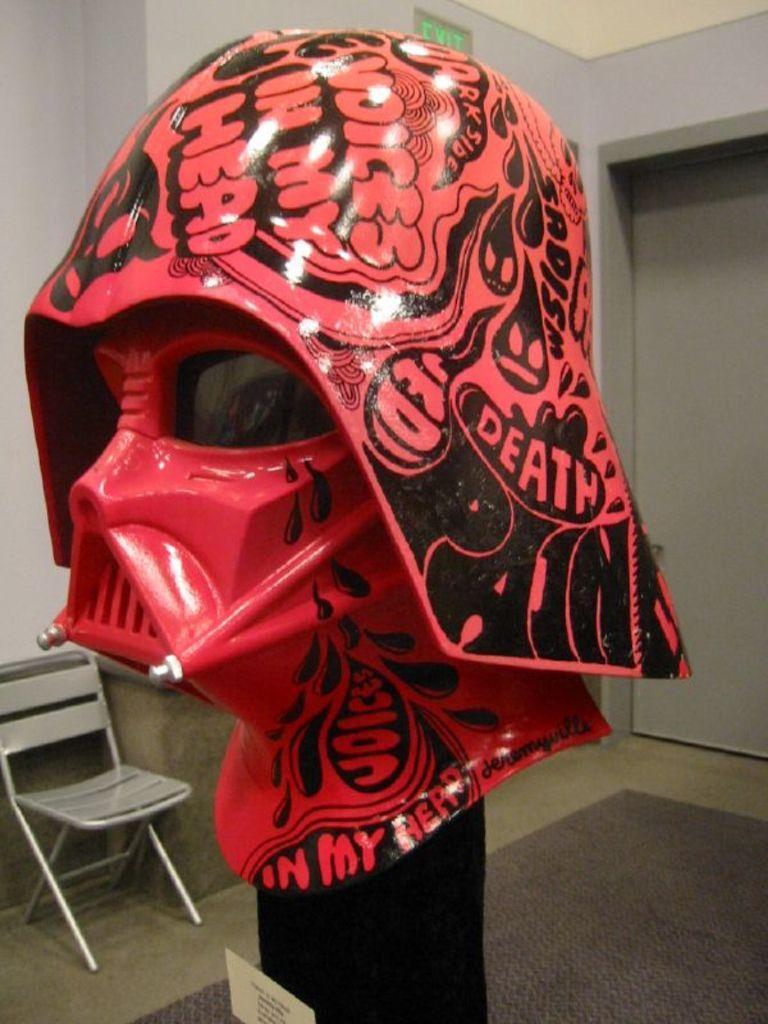In one or two sentences, can you explain what this image depicts? In the picture we can see a mask with a cap which is pink in color and some designs on it and in the background, we can see a chair to the floor and we can also see a wall with a door and an exit board to it. 